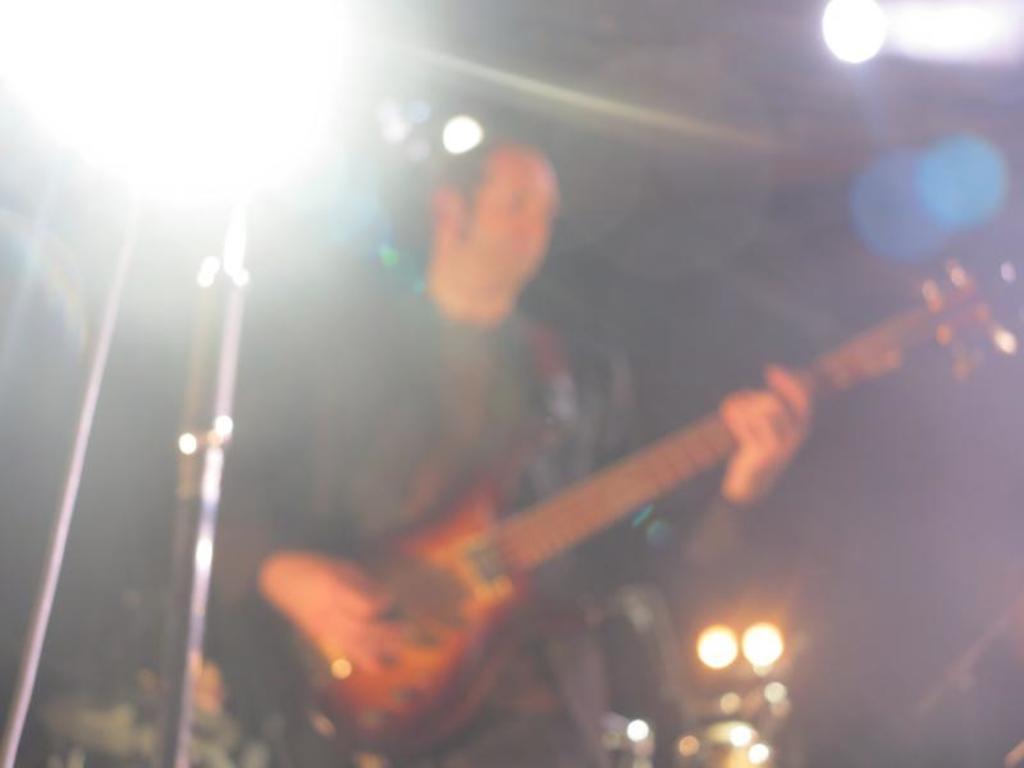Describe this image in one or two sentences. In this image, there is a person standing and playing a guitar. This person is wearing clothes. 